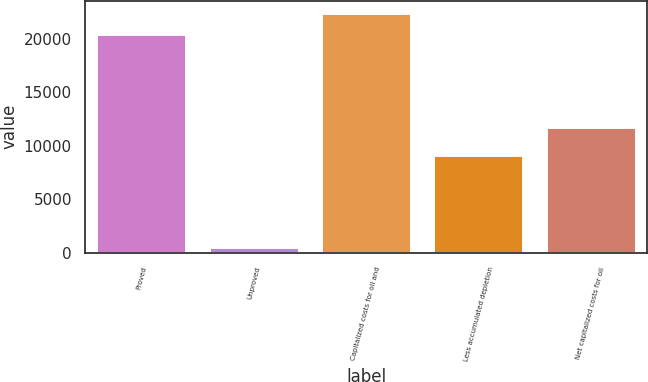Convert chart to OTSL. <chart><loc_0><loc_0><loc_500><loc_500><bar_chart><fcel>Proved<fcel>Unproved<fcel>Capitalized costs for oil and<fcel>Less accumulated depletion<fcel>Net capitalized costs for oil<nl><fcel>20404<fcel>558<fcel>22444.4<fcel>9196<fcel>11766<nl></chart> 